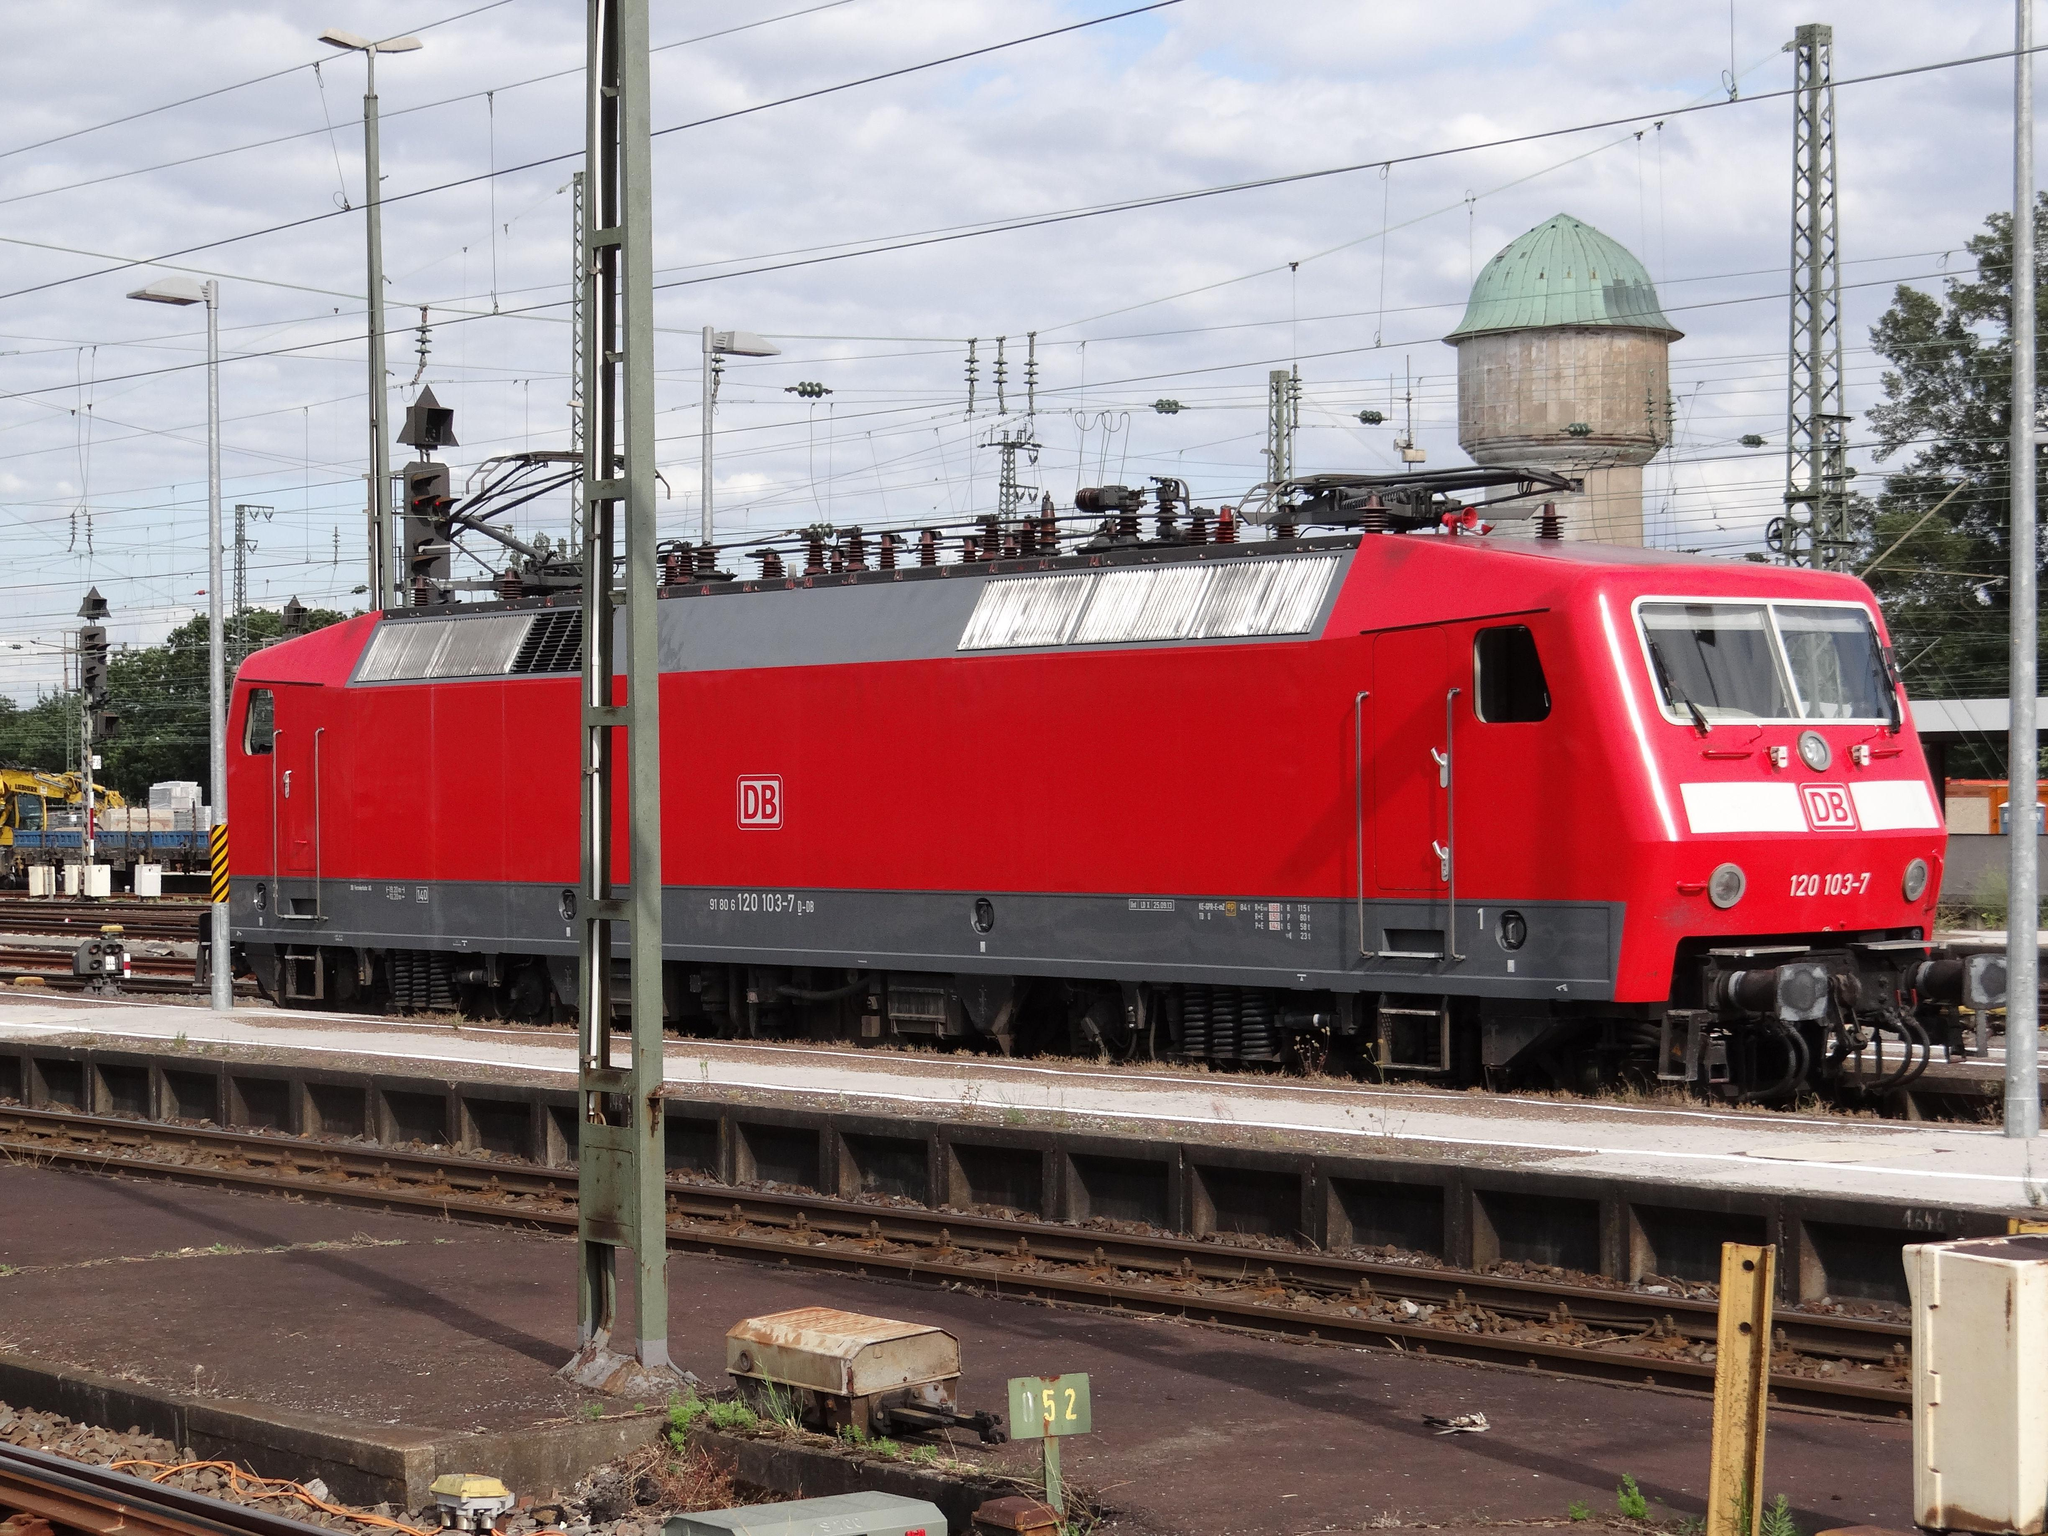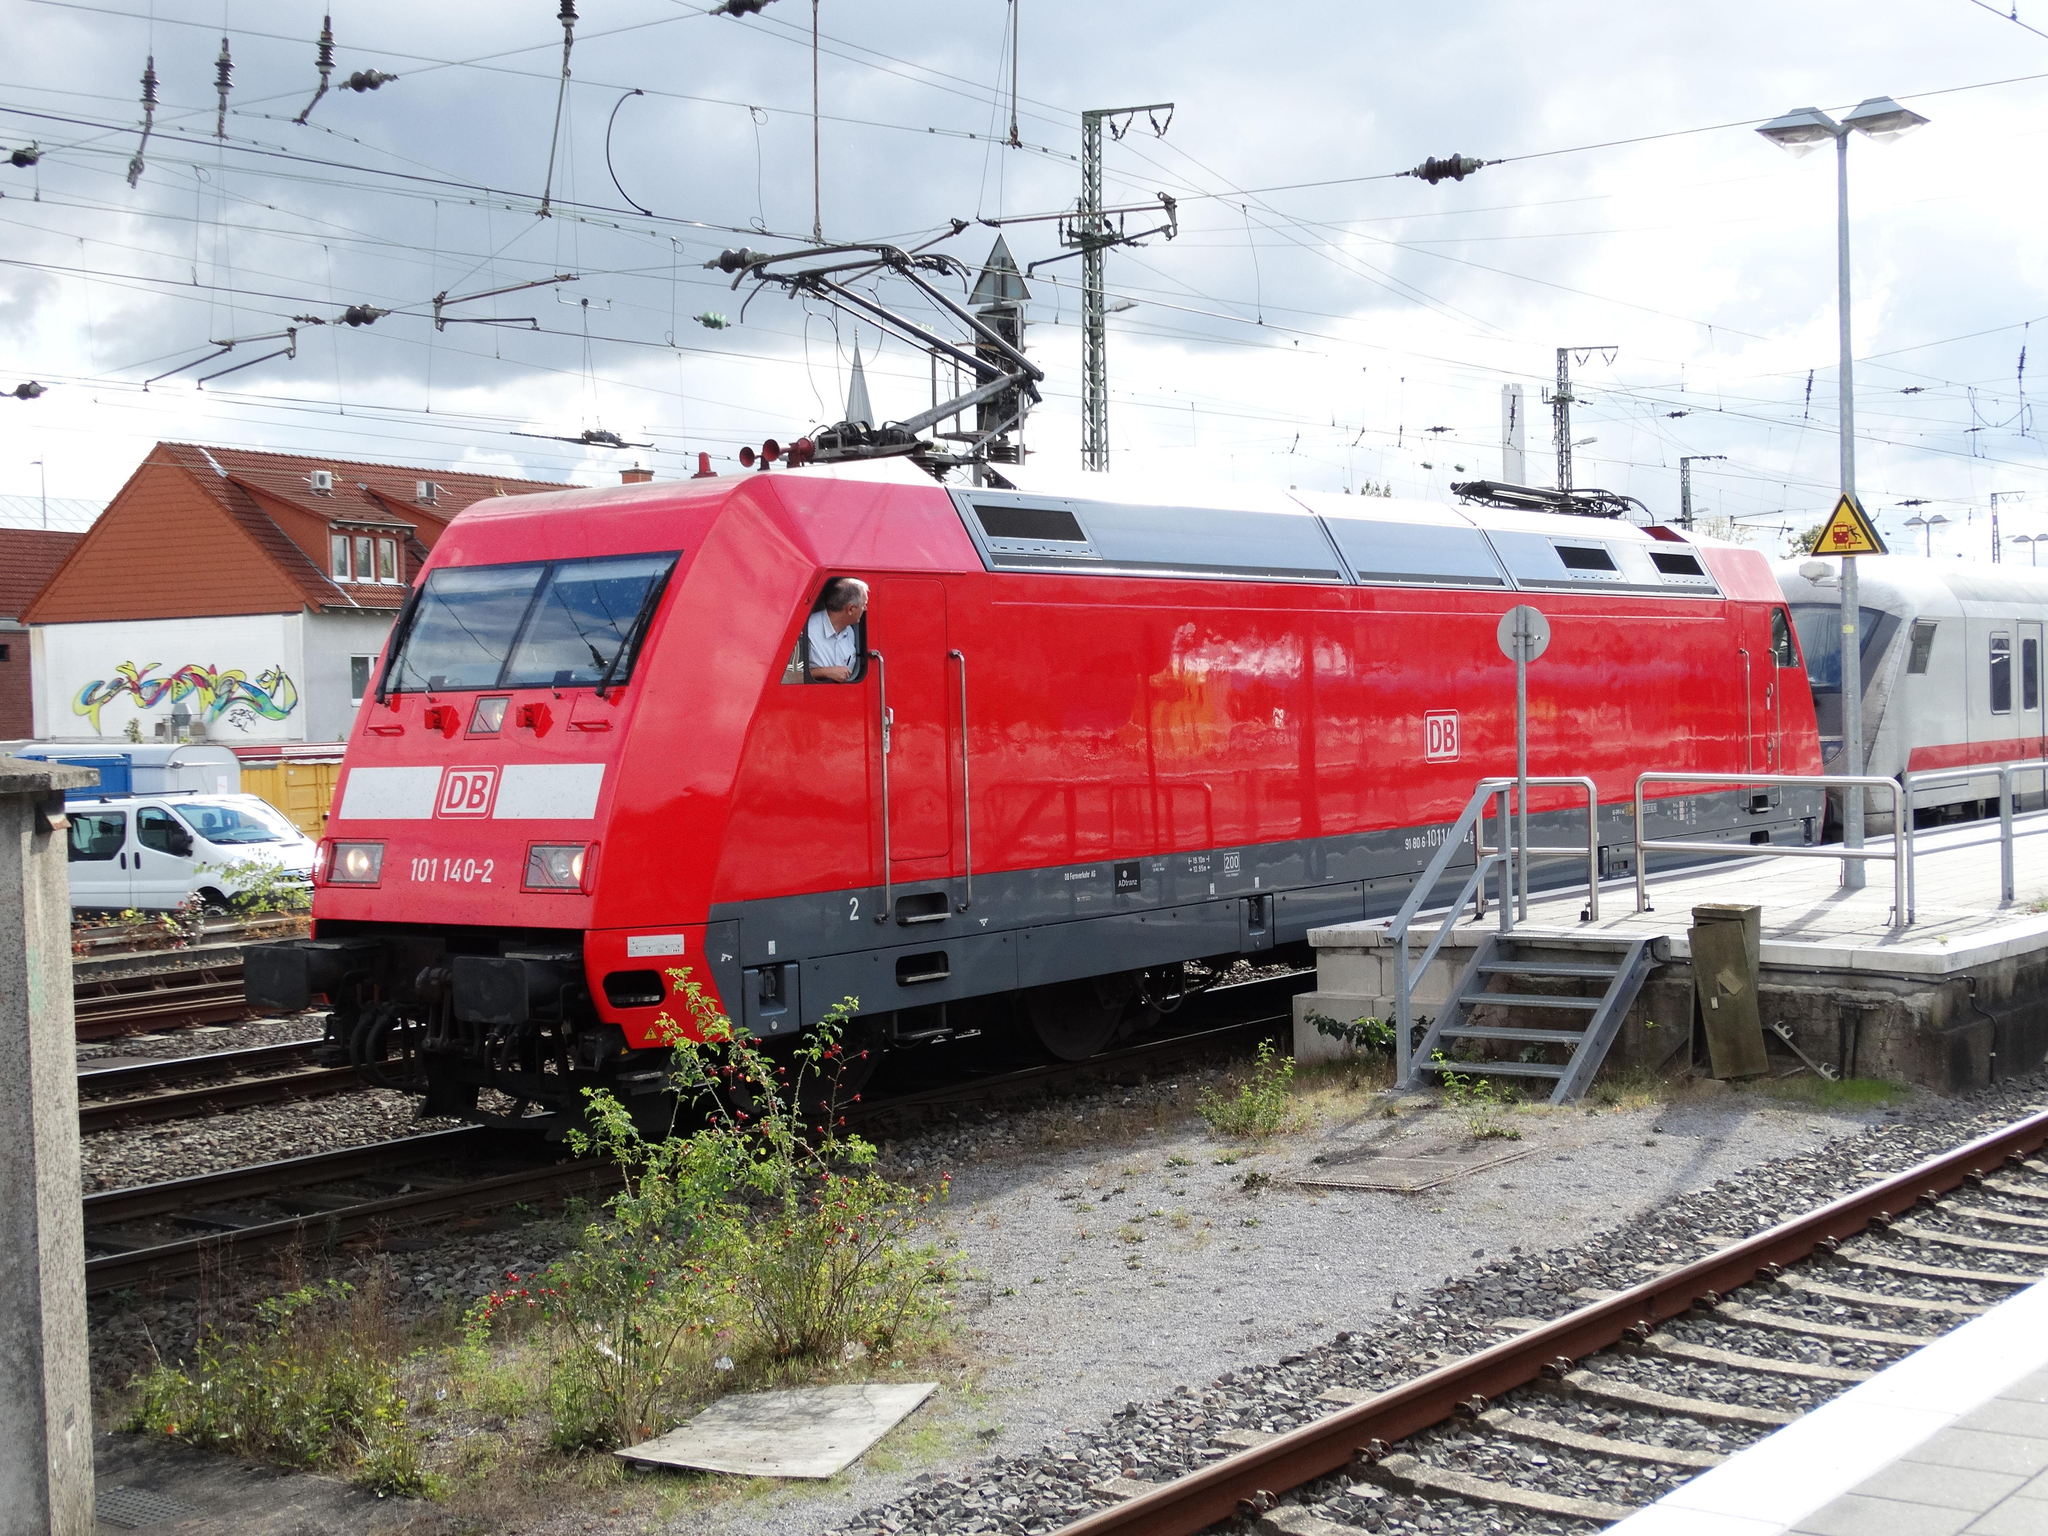The first image is the image on the left, the second image is the image on the right. Evaluate the accuracy of this statement regarding the images: "Trains in right and left images are true red and face different directions.". Is it true? Answer yes or no. Yes. The first image is the image on the left, the second image is the image on the right. Given the left and right images, does the statement "There is exactly one power pole in the image on the left" hold true? Answer yes or no. No. 